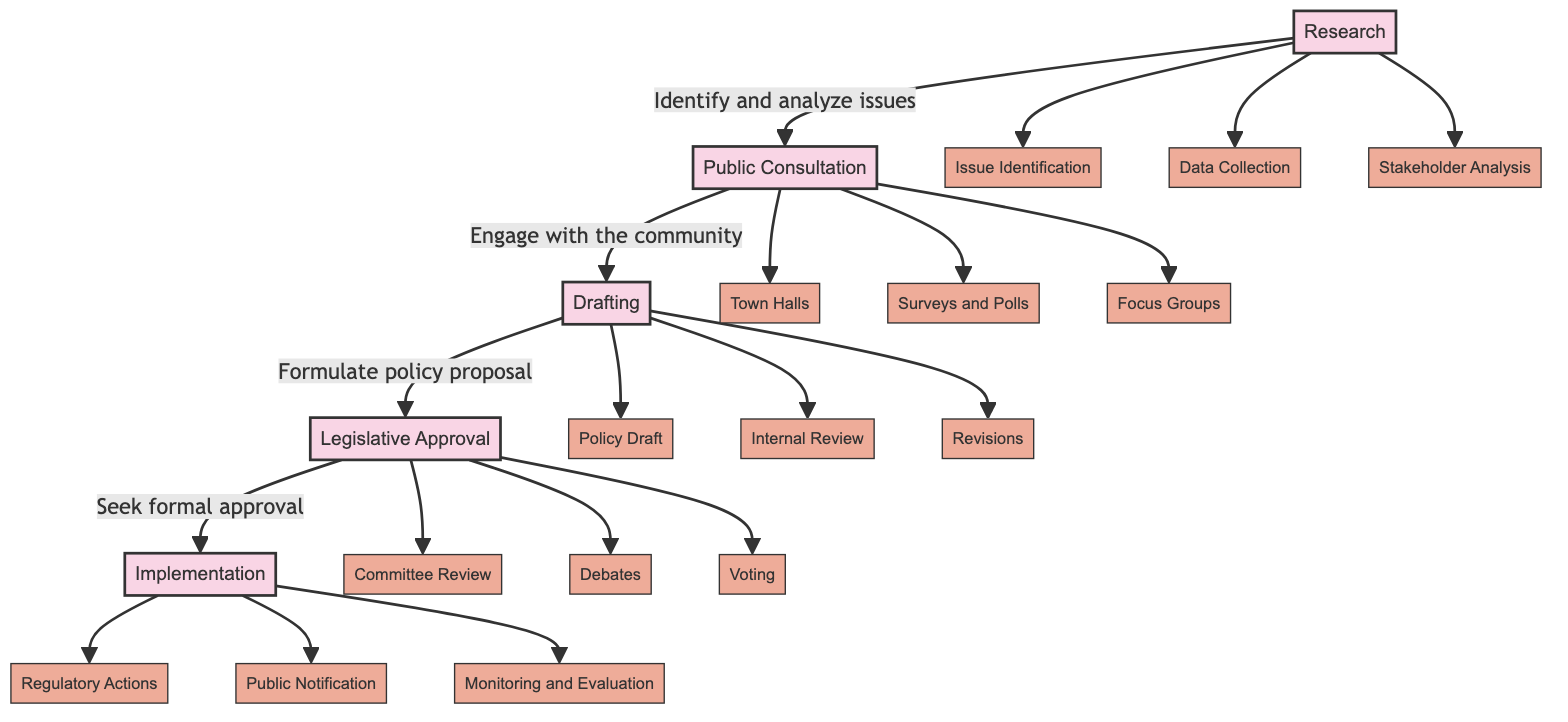What is the first stage of policy development? The diagram indicates that "Research" is the first node and represents the starting stage of the policy development lifecycle.
Answer: Research How many main nodes are there in the diagram? By reviewing the diagram, we can count five main nodes: Research, Public Consultation, Drafting, Legislative Approval, and Implementation.
Answer: 5 What follows after Public Consultation? From the flowchart, it can be observed that "Drafting" immediately follows "Public Consultation."
Answer: Drafting Which node is associated with "Seek formal approval"? The flow of the diagram shows that "Legislative Approval" is the node where the action "Seek formal approval" takes place.
Answer: Legislative Approval What types of activities are included in the Research stage? Analyzing the Research node, it breaks down into three activities: Issue Identification, Data Collection, and Stakeholder Analysis.
Answer: Issue Identification, Data Collection, Stakeholder Analysis Which node leads to "Public Notification"? The diagram indicates that "Implementation" is the node that leads to "Public Notification" as part of its processes.
Answer: Implementation What is the last step in the policy development lifecycle? The final node in the diagram is "Implementation," indicating that this is the last step in the policy development lifecycle.
Answer: Implementation During which stage are Town Halls held? Referring to the Public Consultation node, it specifically mentions "Town Halls" as one of the activities associated with this stage.
Answer: Public Consultation What are the three sub-tasks in the Drafting phase? Within the Drafting node, three sub-tasks are listed: Policy Draft, Internal Review, and Revisions.
Answer: Policy Draft, Internal Review, Revisions 